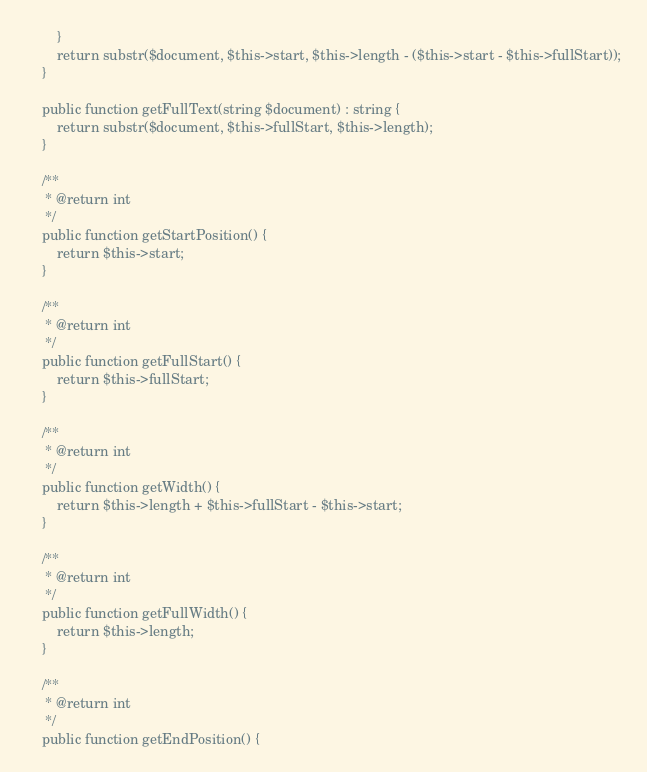<code> <loc_0><loc_0><loc_500><loc_500><_PHP_>        }
        return substr($document, $this->start, $this->length - ($this->start - $this->fullStart));
    }

    public function getFullText(string $document) : string {
        return substr($document, $this->fullStart, $this->length);
    }

    /**
     * @return int
     */
    public function getStartPosition() {
        return $this->start;
    }

    /**
     * @return int
     */
    public function getFullStart() {
        return $this->fullStart;
    }

    /**
     * @return int
     */
    public function getWidth() {
        return $this->length + $this->fullStart - $this->start;
    }

    /**
     * @return int
     */
    public function getFullWidth() {
        return $this->length;
    }

    /**
     * @return int
     */
    public function getEndPosition() {</code> 